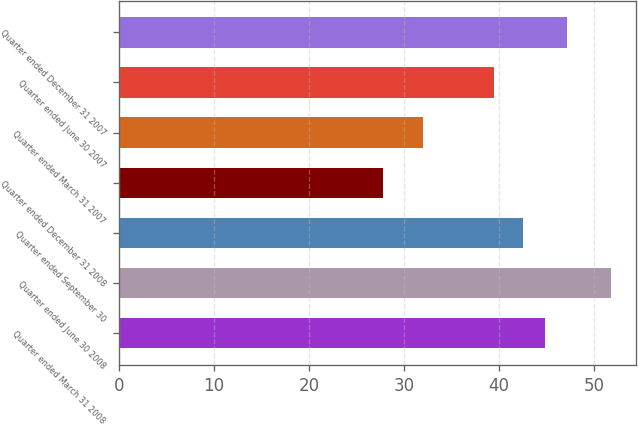<chart> <loc_0><loc_0><loc_500><loc_500><bar_chart><fcel>Quarter ended March 31 2008<fcel>Quarter ended June 30 2008<fcel>Quarter ended September 30<fcel>Quarter ended December 31 2008<fcel>Quarter ended March 31 2007<fcel>Quarter ended June 30 2007<fcel>Quarter ended December 31 2007<nl><fcel>44.81<fcel>51.77<fcel>42.49<fcel>27.76<fcel>32<fcel>39.43<fcel>47.13<nl></chart> 